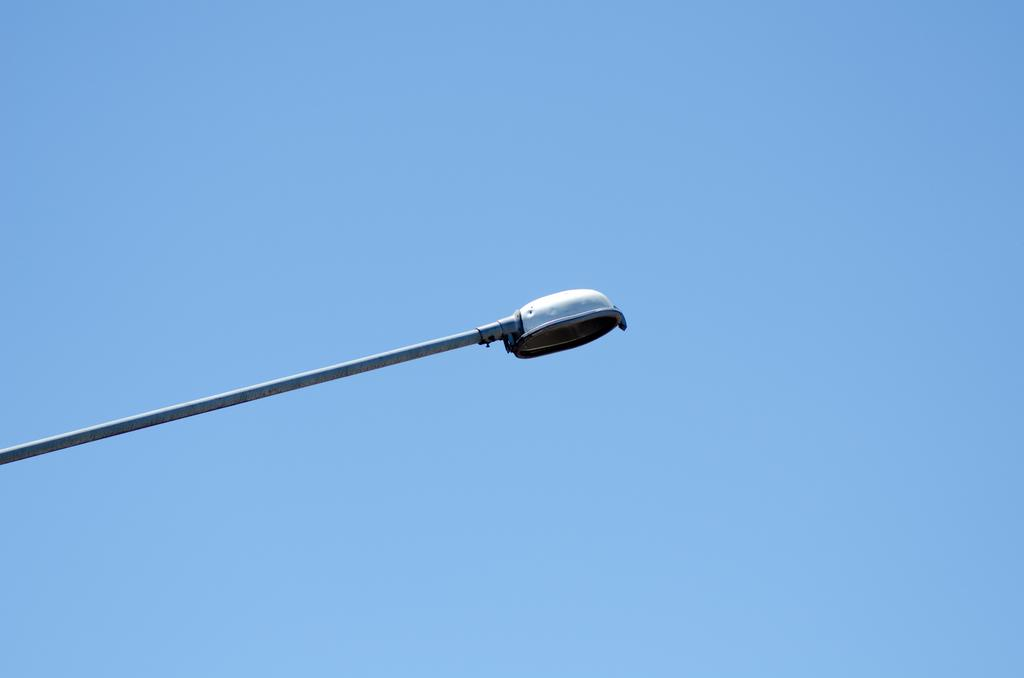What is the main object in the image? There is a street light in the image. What can be seen in the background of the image? The sky is visible in the background of the image. Where is the shelf located in the image? There is no shelf present in the image. What type of rest can be seen in the image? There is no rest or resting object visible in the image. 